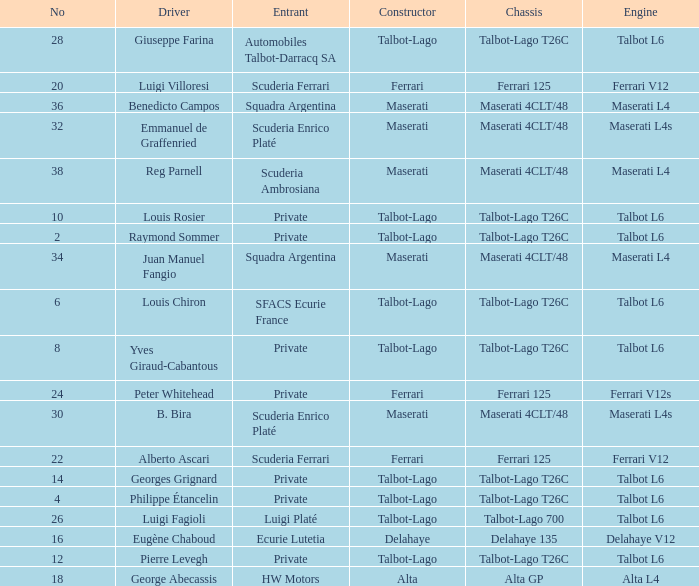Name the chassis for sfacs ecurie france Talbot-Lago T26C. 